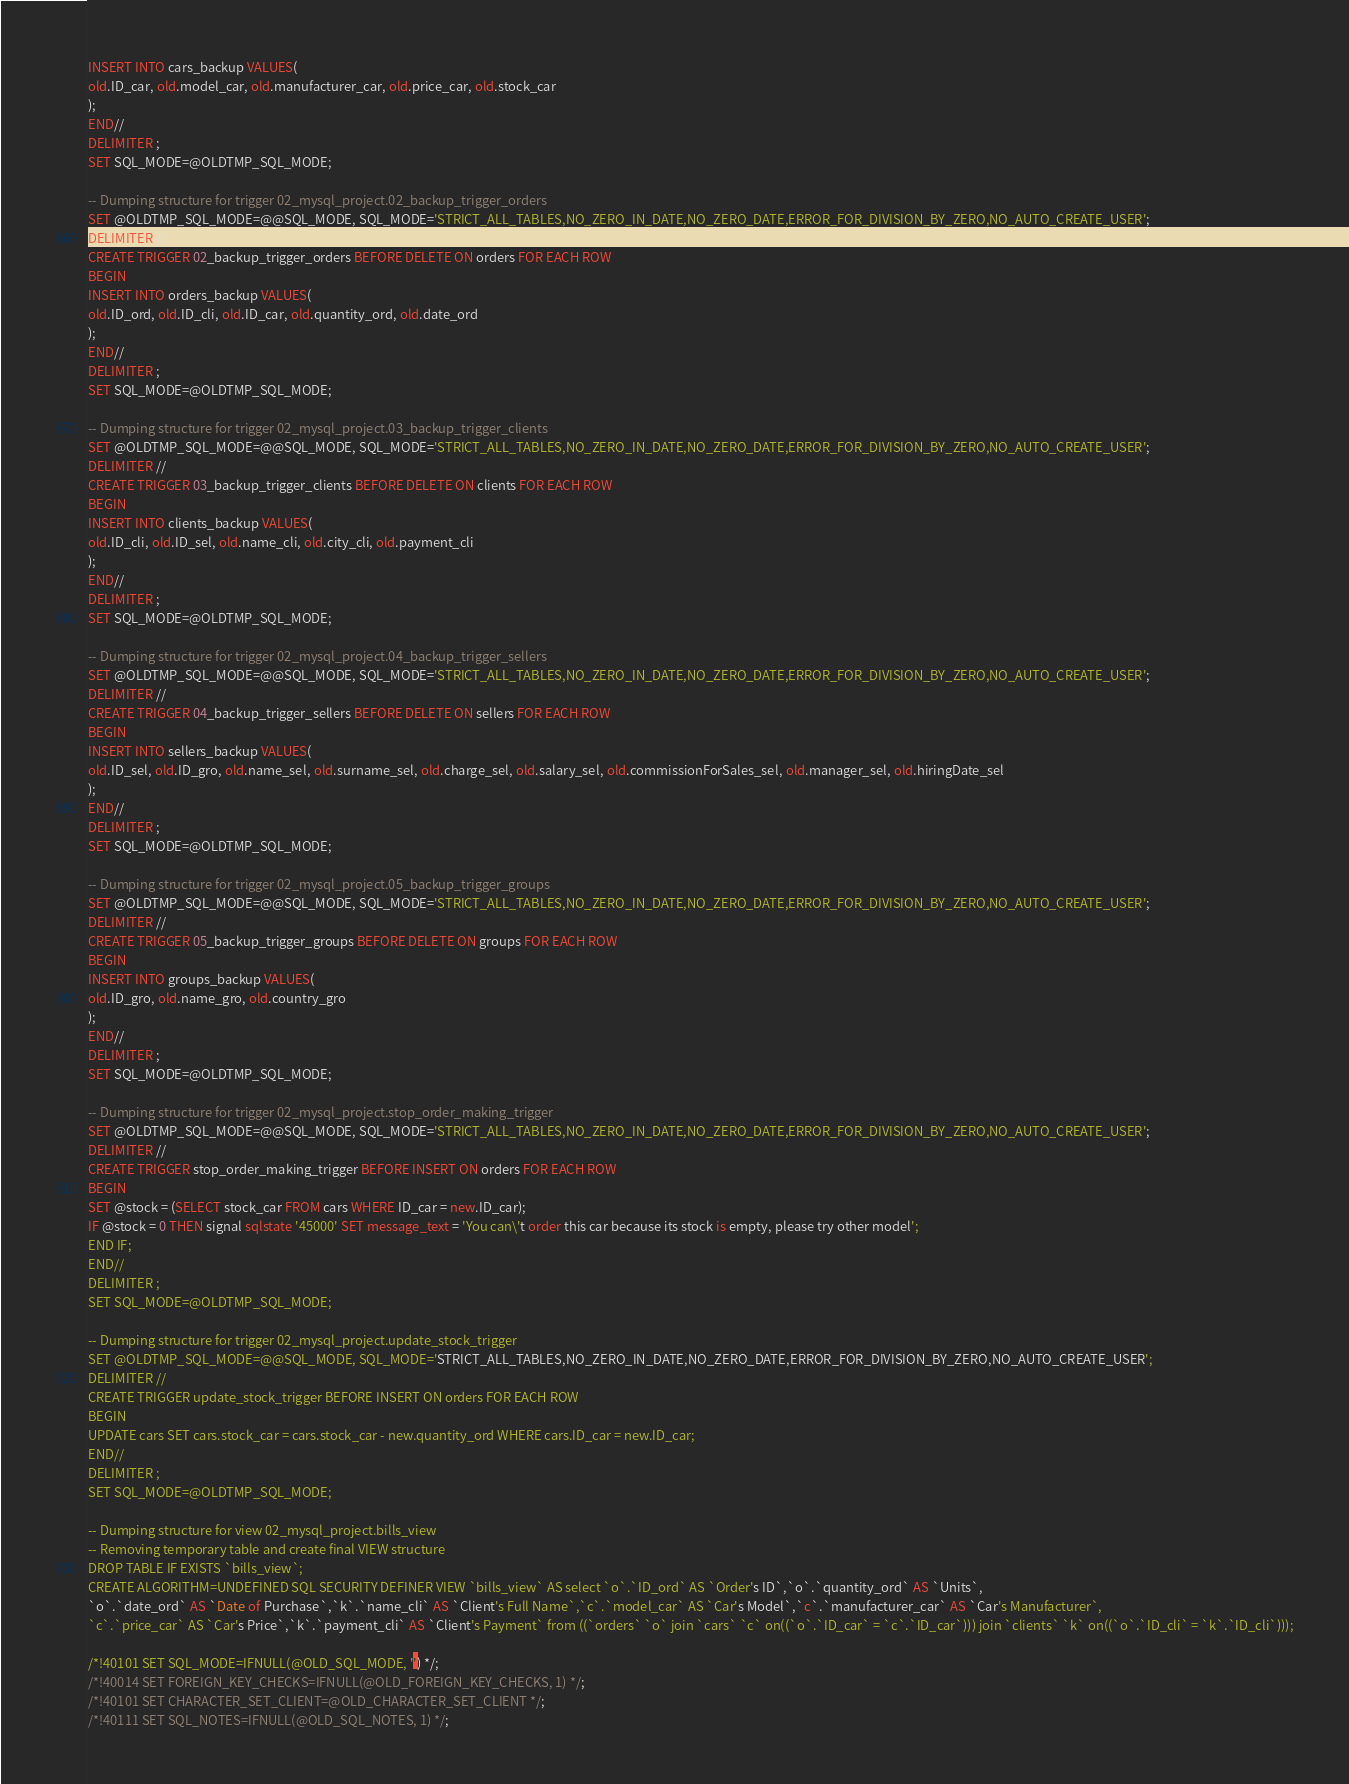Convert code to text. <code><loc_0><loc_0><loc_500><loc_500><_SQL_>INSERT INTO cars_backup VALUES(
old.ID_car, old.model_car, old.manufacturer_car, old.price_car, old.stock_car
);
END//
DELIMITER ;
SET SQL_MODE=@OLDTMP_SQL_MODE;

-- Dumping structure for trigger 02_mysql_project.02_backup_trigger_orders
SET @OLDTMP_SQL_MODE=@@SQL_MODE, SQL_MODE='STRICT_ALL_TABLES,NO_ZERO_IN_DATE,NO_ZERO_DATE,ERROR_FOR_DIVISION_BY_ZERO,NO_AUTO_CREATE_USER';
DELIMITER //
CREATE TRIGGER 02_backup_trigger_orders BEFORE DELETE ON orders FOR EACH ROW
BEGIN
INSERT INTO orders_backup VALUES(
old.ID_ord, old.ID_cli, old.ID_car, old.quantity_ord, old.date_ord
);
END//
DELIMITER ;
SET SQL_MODE=@OLDTMP_SQL_MODE;

-- Dumping structure for trigger 02_mysql_project.03_backup_trigger_clients
SET @OLDTMP_SQL_MODE=@@SQL_MODE, SQL_MODE='STRICT_ALL_TABLES,NO_ZERO_IN_DATE,NO_ZERO_DATE,ERROR_FOR_DIVISION_BY_ZERO,NO_AUTO_CREATE_USER';
DELIMITER //
CREATE TRIGGER 03_backup_trigger_clients BEFORE DELETE ON clients FOR EACH ROW
BEGIN
INSERT INTO clients_backup VALUES(
old.ID_cli, old.ID_sel, old.name_cli, old.city_cli, old.payment_cli
);
END//
DELIMITER ;
SET SQL_MODE=@OLDTMP_SQL_MODE;

-- Dumping structure for trigger 02_mysql_project.04_backup_trigger_sellers
SET @OLDTMP_SQL_MODE=@@SQL_MODE, SQL_MODE='STRICT_ALL_TABLES,NO_ZERO_IN_DATE,NO_ZERO_DATE,ERROR_FOR_DIVISION_BY_ZERO,NO_AUTO_CREATE_USER';
DELIMITER //
CREATE TRIGGER 04_backup_trigger_sellers BEFORE DELETE ON sellers FOR EACH ROW
BEGIN
INSERT INTO sellers_backup VALUES(
old.ID_sel, old.ID_gro, old.name_sel, old.surname_sel, old.charge_sel, old.salary_sel, old.commissionForSales_sel, old.manager_sel, old.hiringDate_sel
);
END//
DELIMITER ;
SET SQL_MODE=@OLDTMP_SQL_MODE;

-- Dumping structure for trigger 02_mysql_project.05_backup_trigger_groups
SET @OLDTMP_SQL_MODE=@@SQL_MODE, SQL_MODE='STRICT_ALL_TABLES,NO_ZERO_IN_DATE,NO_ZERO_DATE,ERROR_FOR_DIVISION_BY_ZERO,NO_AUTO_CREATE_USER';
DELIMITER //
CREATE TRIGGER 05_backup_trigger_groups BEFORE DELETE ON groups FOR EACH ROW
BEGIN
INSERT INTO groups_backup VALUES(
old.ID_gro, old.name_gro, old.country_gro
);
END//
DELIMITER ;
SET SQL_MODE=@OLDTMP_SQL_MODE;

-- Dumping structure for trigger 02_mysql_project.stop_order_making_trigger
SET @OLDTMP_SQL_MODE=@@SQL_MODE, SQL_MODE='STRICT_ALL_TABLES,NO_ZERO_IN_DATE,NO_ZERO_DATE,ERROR_FOR_DIVISION_BY_ZERO,NO_AUTO_CREATE_USER';
DELIMITER //
CREATE TRIGGER stop_order_making_trigger BEFORE INSERT ON orders FOR EACH ROW
BEGIN 
SET @stock = (SELECT stock_car FROM cars WHERE ID_car = new.ID_car);
IF @stock = 0 THEN signal sqlstate '45000' SET message_text = 'You can\'t order this car because its stock is empty, please try other model';
END IF;
END//
DELIMITER ;
SET SQL_MODE=@OLDTMP_SQL_MODE;

-- Dumping structure for trigger 02_mysql_project.update_stock_trigger
SET @OLDTMP_SQL_MODE=@@SQL_MODE, SQL_MODE='STRICT_ALL_TABLES,NO_ZERO_IN_DATE,NO_ZERO_DATE,ERROR_FOR_DIVISION_BY_ZERO,NO_AUTO_CREATE_USER';
DELIMITER //
CREATE TRIGGER update_stock_trigger BEFORE INSERT ON orders FOR EACH ROW
BEGIN
UPDATE cars SET cars.stock_car = cars.stock_car - new.quantity_ord WHERE cars.ID_car = new.ID_car;
END//
DELIMITER ;
SET SQL_MODE=@OLDTMP_SQL_MODE;

-- Dumping structure for view 02_mysql_project.bills_view
-- Removing temporary table and create final VIEW structure
DROP TABLE IF EXISTS `bills_view`;
CREATE ALGORITHM=UNDEFINED SQL SECURITY DEFINER VIEW `bills_view` AS select `o`.`ID_ord` AS `Order's ID`,`o`.`quantity_ord` AS `Units`,
`o`.`date_ord` AS `Date of Purchase`,`k`.`name_cli` AS `Client's Full Name`,`c`.`model_car` AS `Car's Model`,`c`.`manufacturer_car` AS `Car's Manufacturer`,
`c`.`price_car` AS `Car's Price`,`k`.`payment_cli` AS `Client's Payment` from ((`orders` `o` join `cars` `c` on((`o`.`ID_car` = `c`.`ID_car`))) join `clients` `k` on((`o`.`ID_cli` = `k`.`ID_cli`)));

/*!40101 SET SQL_MODE=IFNULL(@OLD_SQL_MODE, '') */;
/*!40014 SET FOREIGN_KEY_CHECKS=IFNULL(@OLD_FOREIGN_KEY_CHECKS, 1) */;
/*!40101 SET CHARACTER_SET_CLIENT=@OLD_CHARACTER_SET_CLIENT */;
/*!40111 SET SQL_NOTES=IFNULL(@OLD_SQL_NOTES, 1) */;
</code> 